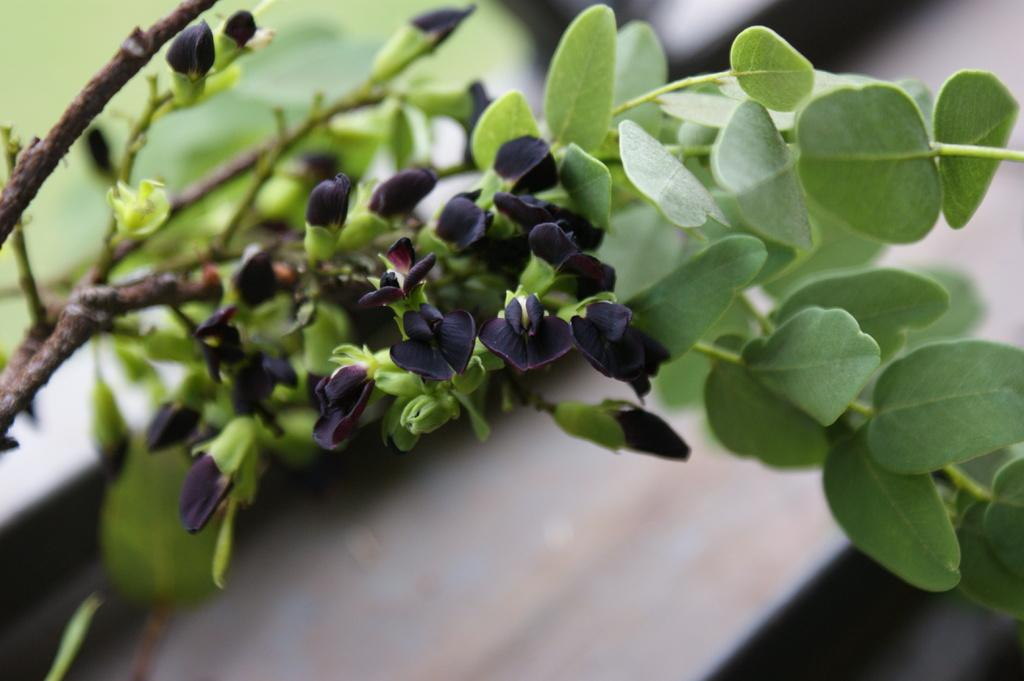What type of flora can be seen in the image? There are flowers and plants in the image. Can you describe the background of the image? The background of the image is blurry. What year is depicted in the image? There is no specific year depicted in the image, as it features flowers and plants. Are there any snakes visible in the image? There are no snakes present in the image; it features flowers and plants. 